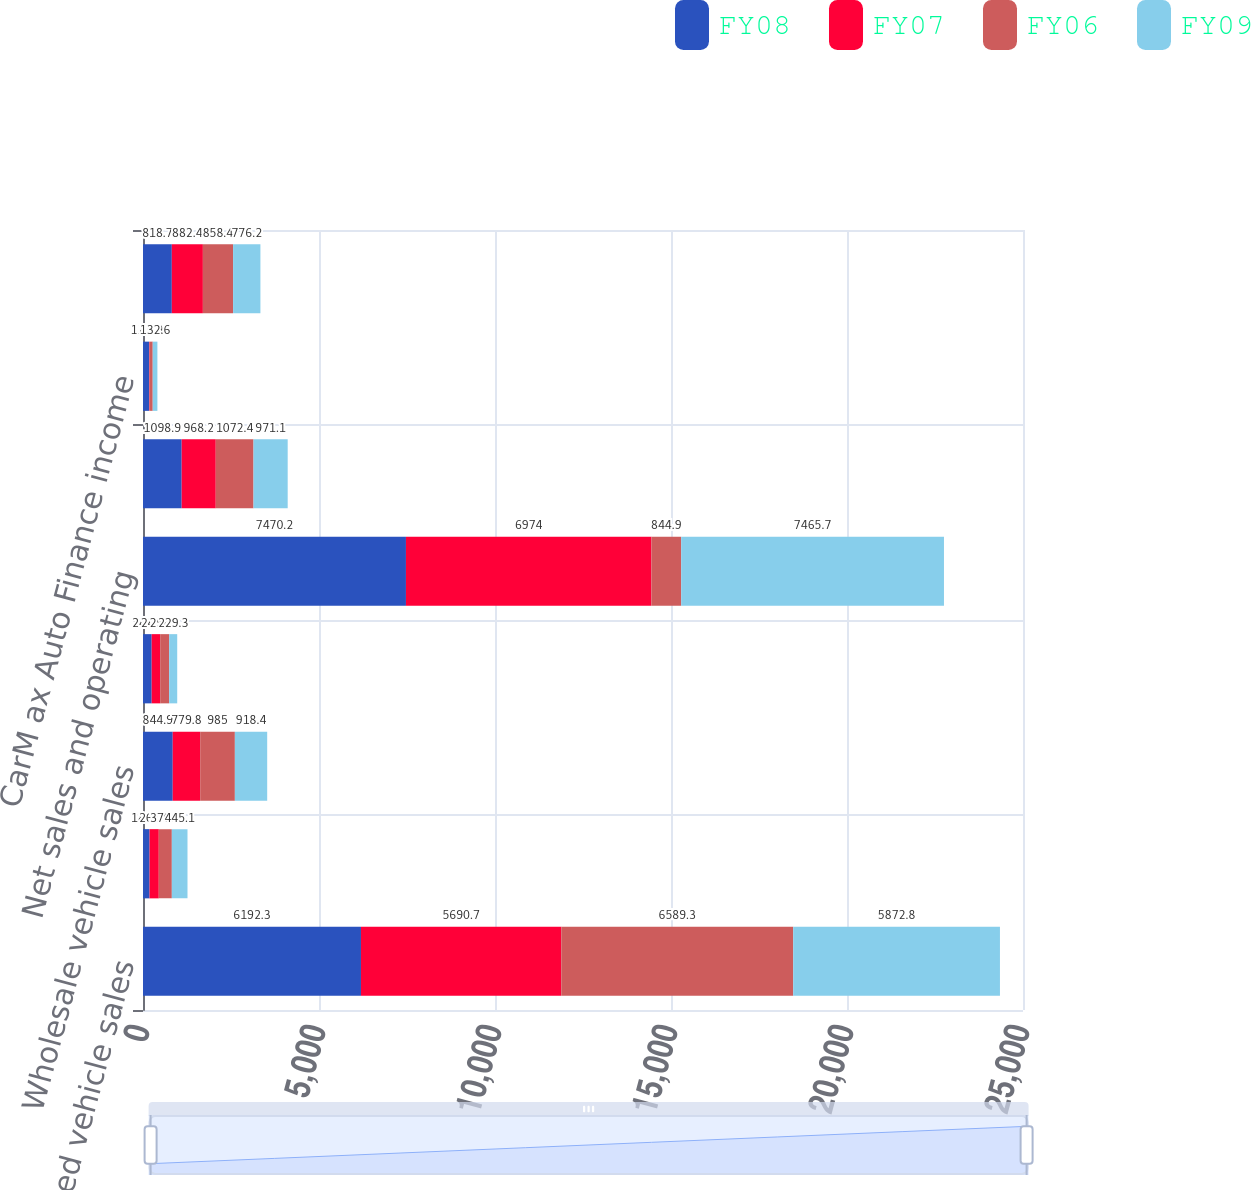<chart> <loc_0><loc_0><loc_500><loc_500><stacked_bar_chart><ecel><fcel>Used vehicle sales<fcel>New vehicle sales<fcel>Wholesale vehicle sales<fcel>Other sales and revenues<fcel>Net sales and operating<fcel>Gross profit<fcel>CarM ax Auto Finance income<fcel>SG&A<nl><fcel>FY08<fcel>6192.3<fcel>186.5<fcel>844.9<fcel>246.6<fcel>7470.2<fcel>1098.9<fcel>175.2<fcel>818.7<nl><fcel>FY07<fcel>5690.7<fcel>261.9<fcel>779.8<fcel>241.6<fcel>6974<fcel>968.2<fcel>15.3<fcel>882.4<nl><fcel>FY06<fcel>6589.3<fcel>370.6<fcel>985<fcel>254.6<fcel>844.9<fcel>1072.4<fcel>85.9<fcel>858.4<nl><fcel>FY09<fcel>5872.8<fcel>445.1<fcel>918.4<fcel>229.3<fcel>7465.7<fcel>971.1<fcel>132.6<fcel>776.2<nl></chart> 